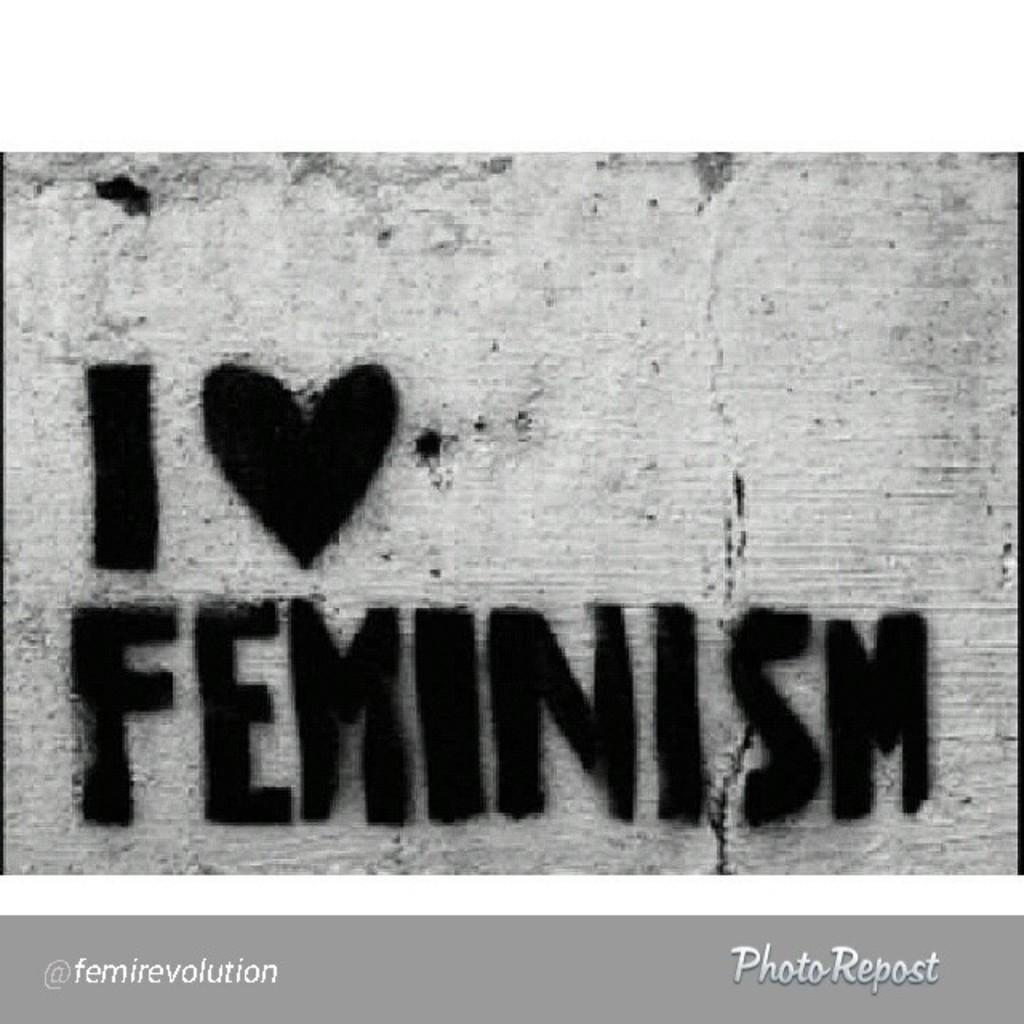<image>
Give a short and clear explanation of the subsequent image. A spray painted stencil with black paint displays the message about loving feminism. 